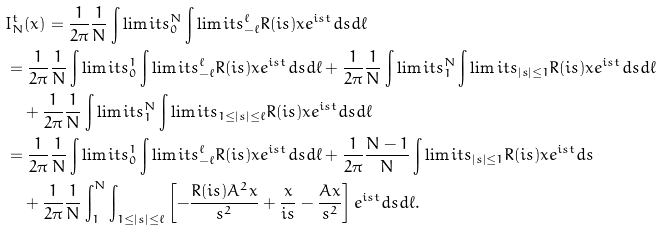Convert formula to latex. <formula><loc_0><loc_0><loc_500><loc_500>& I _ { N } ^ { t } ( x ) = \frac { 1 } { 2 \pi } \frac { 1 } { N } \int \lim i t s _ { 0 } ^ { N } \int \lim i t s _ { - \ell } ^ { \ell } R ( i s ) x e ^ { i s t } d s d \ell \\ & = \frac { 1 } { 2 \pi } \frac { 1 } { N } \int \lim i t s _ { 0 } ^ { 1 } \int \lim i t s _ { - \ell } ^ { \ell } R ( i s ) x e ^ { i s t } d s d \ell + \frac { 1 } { 2 \pi } \frac { 1 } { N } \int \lim i t s _ { 1 } ^ { N } \int \lim i t s _ { | s | \leq 1 } R ( i s ) x e ^ { i s t } d s d \ell \\ & \quad + \frac { 1 } { 2 \pi } \frac { 1 } { N } \int \lim i t s _ { 1 } ^ { N } \int \lim i t s _ { 1 \leq | s | \leq \ell } R ( i s ) x e ^ { i s t } d s d \ell \\ & = \frac { 1 } { 2 \pi } \frac { 1 } { N } \int \lim i t s _ { 0 } ^ { 1 } \int \lim i t s _ { - \ell } ^ { \ell } R ( i s ) x e ^ { i s t } d s d \ell + \frac { 1 } { 2 \pi } \frac { N - 1 } { N } \int \lim i t s _ { | s | \leq 1 } R ( i s ) x e ^ { i s t } d s \\ & \quad + \frac { 1 } { 2 \pi } \frac { 1 } { N } \int _ { 1 } ^ { N } \int _ { 1 \leq | s | \leq \ell } \left [ - \frac { R ( i s ) A ^ { 2 } x } { s ^ { 2 } } + \frac { x } { i s } - \frac { A x } { s ^ { 2 } } \right ] e ^ { i s t } d s d \ell .</formula> 